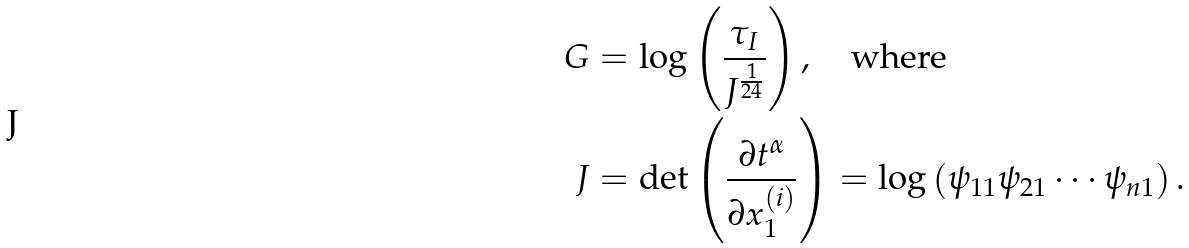Convert formula to latex. <formula><loc_0><loc_0><loc_500><loc_500>G & = \log \left ( \frac { \tau _ { I } } { J ^ { \frac { 1 } { 2 4 } } } \right ) , \quad \text {where} \\ J & = \det \left ( \frac { \partial t ^ { \alpha } } { \partial x _ { 1 } ^ { ( i ) } } \right ) = \log \left ( \psi _ { 1 1 } \psi _ { 2 1 } \cdots \psi _ { n 1 } \right ) . \\</formula> 